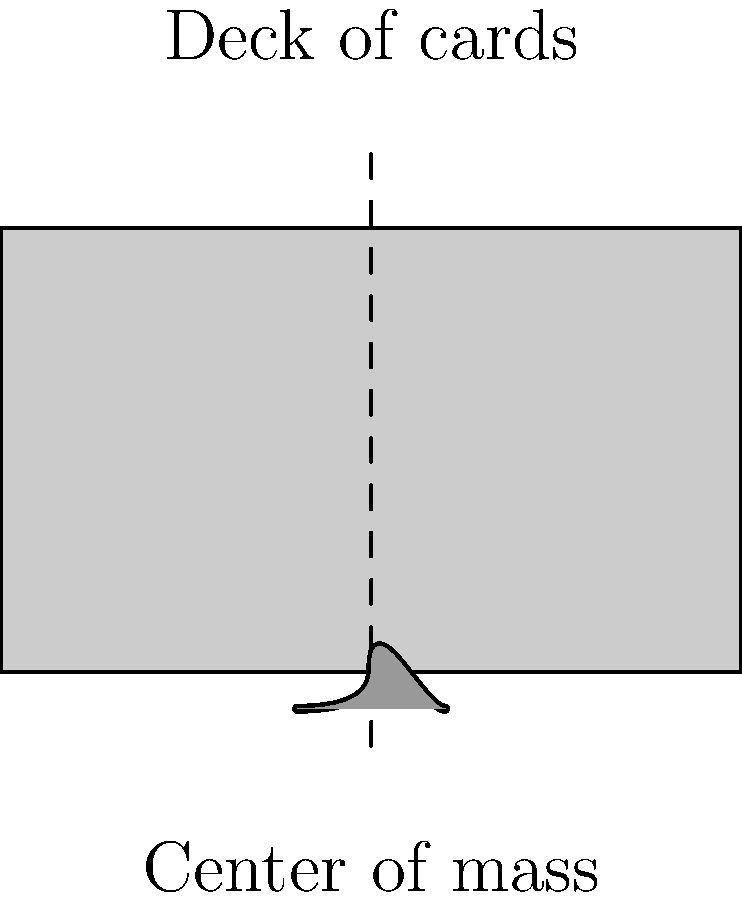As a casino dealer, you're often asked about the physics behind card games. A curious patron asks about the center of mass of a standard deck of cards. If you were to balance the deck on your finger as shown in the illustration, where would the center of mass be located relative to the deck's length? To answer this question, let's consider the properties of a standard deck of cards and the concept of center of mass:

1. A standard deck of cards is uniform in its composition, meaning each card has essentially the same mass and dimensions.

2. The center of mass for a uniform object is located at its geometric center.

3. For a rectangular object like a deck of cards, the geometric center is at the intersection of its diagonals.

4. This point is exactly halfway along the length, width, and height of the deck.

5. In the illustration, the dashed line represents the balance point, which coincides with the center of mass for a uniform object.

6. The balance point is shown to be in the middle of the deck's length.

Therefore, for a standard deck of cards, the center of mass would be located exactly at the midpoint of the deck's length, allowing it to balance perfectly on a finger at that point.
Answer: At the midpoint of the deck's length 